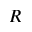Convert formula to latex. <formula><loc_0><loc_0><loc_500><loc_500>R</formula> 